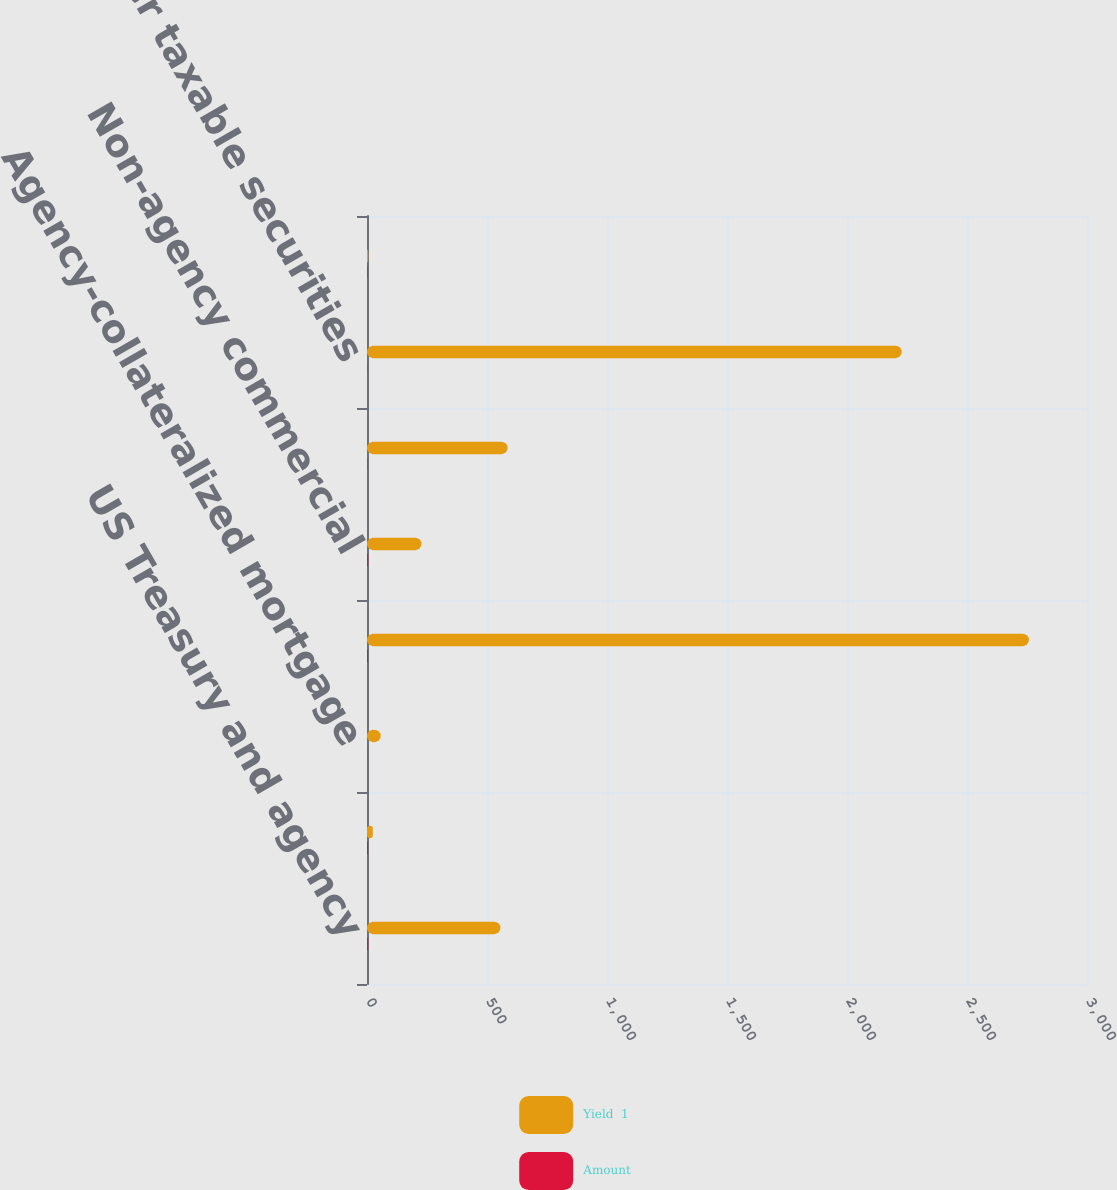<chart> <loc_0><loc_0><loc_500><loc_500><stacked_bar_chart><ecel><fcel>US Treasury and agency<fcel>Agency<fcel>Agency-collateralized mortgage<fcel>Non-agency residential<fcel>Non-agency commercial<fcel>Corporate bonds<fcel>Other taxable securities<fcel>Total taxable securities<nl><fcel>Yield  1<fcel>556<fcel>24<fcel>57<fcel>2758<fcel>227<fcel>586<fcel>2228<fcel>4.9<nl><fcel>Amount<fcel>4.9<fcel>4.4<fcel>0.7<fcel>4.3<fcel>4.9<fcel>1.7<fcel>1.2<fcel>2.37<nl></chart> 